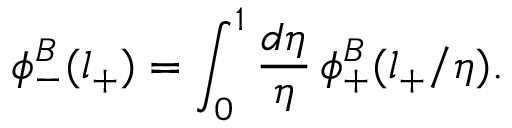<formula> <loc_0><loc_0><loc_500><loc_500>\phi _ { - } ^ { B } ( l _ { + } ) = \int _ { 0 } ^ { 1 } \frac { d \eta } { \eta } \, \phi _ { + } ^ { B } ( l _ { + } / \eta ) .</formula> 